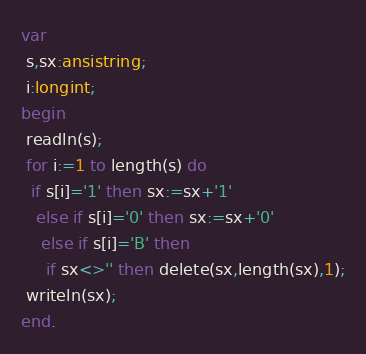Convert code to text. <code><loc_0><loc_0><loc_500><loc_500><_Pascal_>var
 s,sx:ansistring;
 i:longint;
begin
 readln(s);
 for i:=1 to length(s) do
  if s[i]='1' then sx:=sx+'1'
   else if s[i]='0' then sx:=sx+'0'
    else if s[i]='B' then 
     if sx<>'' then delete(sx,length(sx),1);
 writeln(sx);
end.</code> 